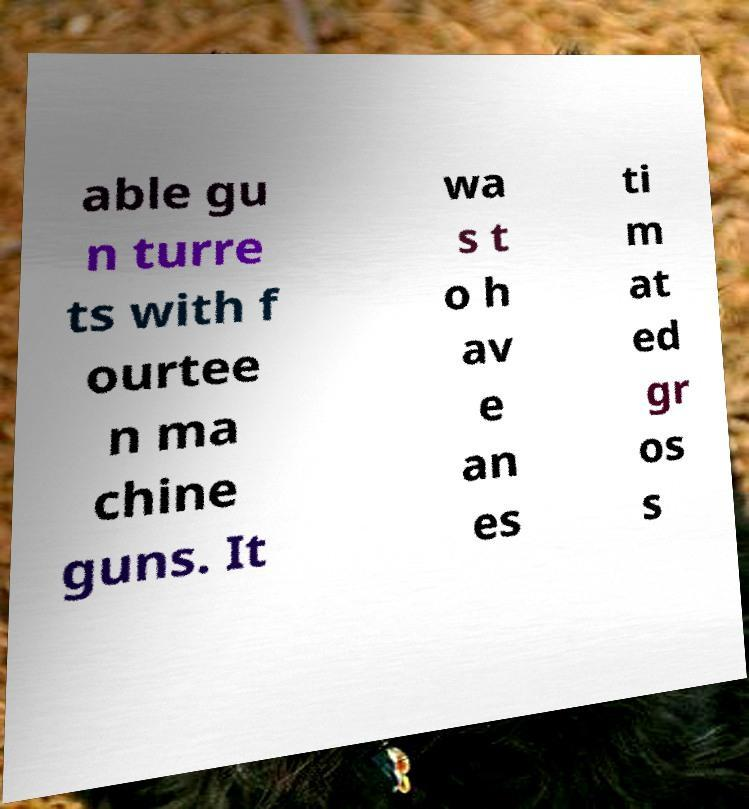Please read and relay the text visible in this image. What does it say? able gu n turre ts with f ourtee n ma chine guns. It wa s t o h av e an es ti m at ed gr os s 